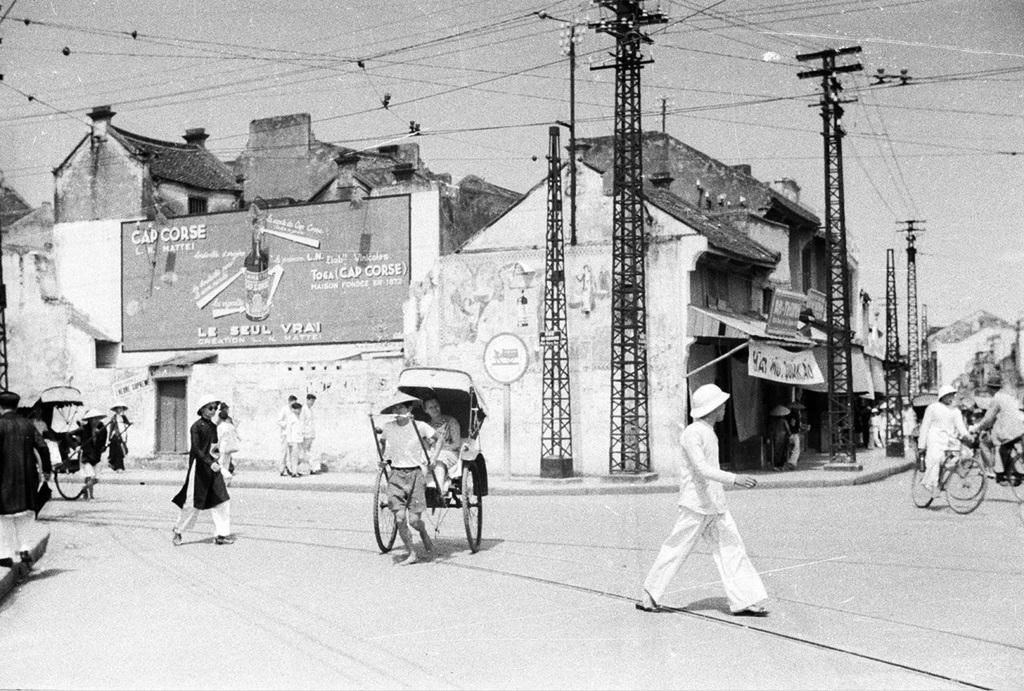Please provide a concise description of this image. In this image there are group of persons walking and riding bicycles. In the center there is a person holding a cart and running. In the background there are poles and buildings and there are wires and boards with some text written on it. 